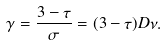<formula> <loc_0><loc_0><loc_500><loc_500>\gamma = \frac { 3 - \tau } { \sigma } = ( 3 - \tau ) D \nu .</formula> 